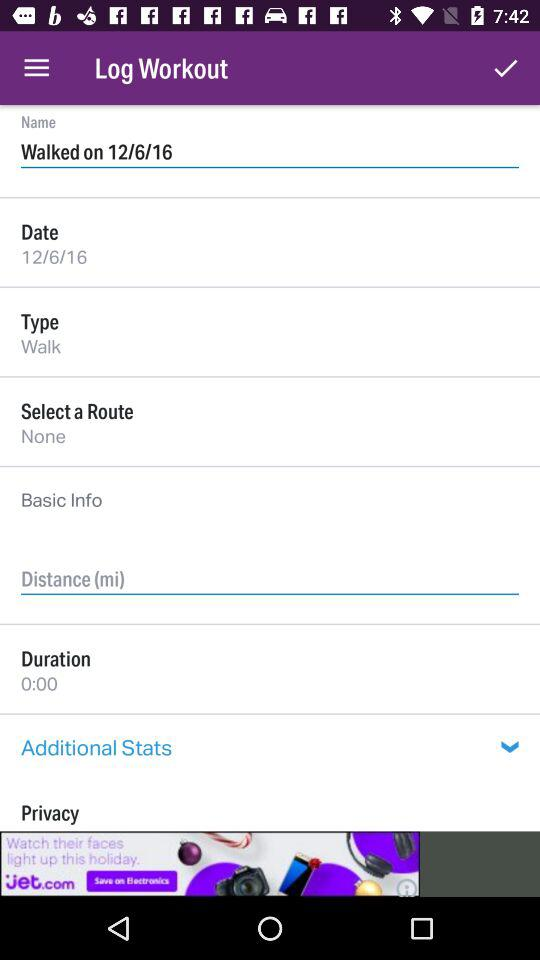What is the duration of the workout?
Answer the question using a single word or phrase. 0:00 